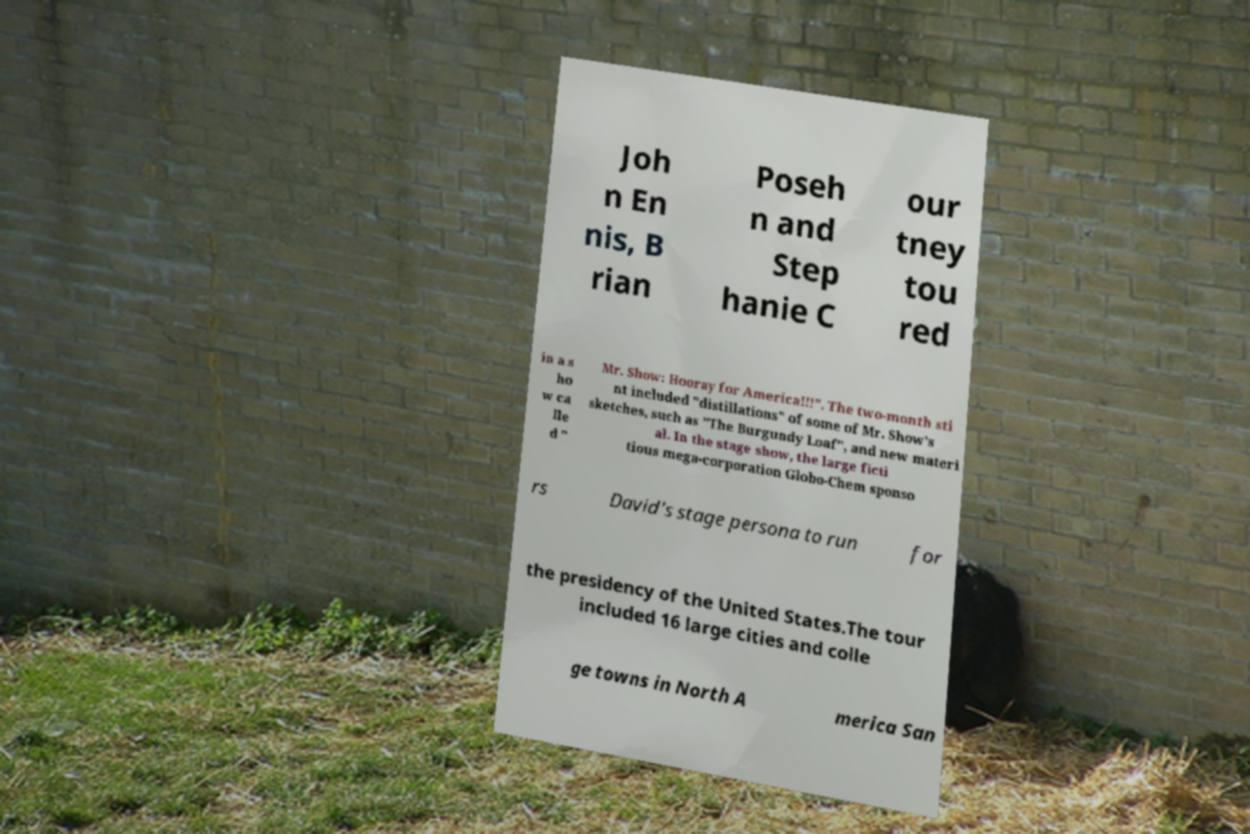Could you extract and type out the text from this image? Joh n En nis, B rian Poseh n and Step hanie C our tney tou red in a s ho w ca lle d " Mr. Show: Hooray for America!!!". The two-month sti nt included "distillations" of some of Mr. Show's sketches, such as "The Burgundy Loaf", and new materi al. In the stage show, the large ficti tious mega-corporation Globo-Chem sponso rs David's stage persona to run for the presidency of the United States.The tour included 16 large cities and colle ge towns in North A merica San 